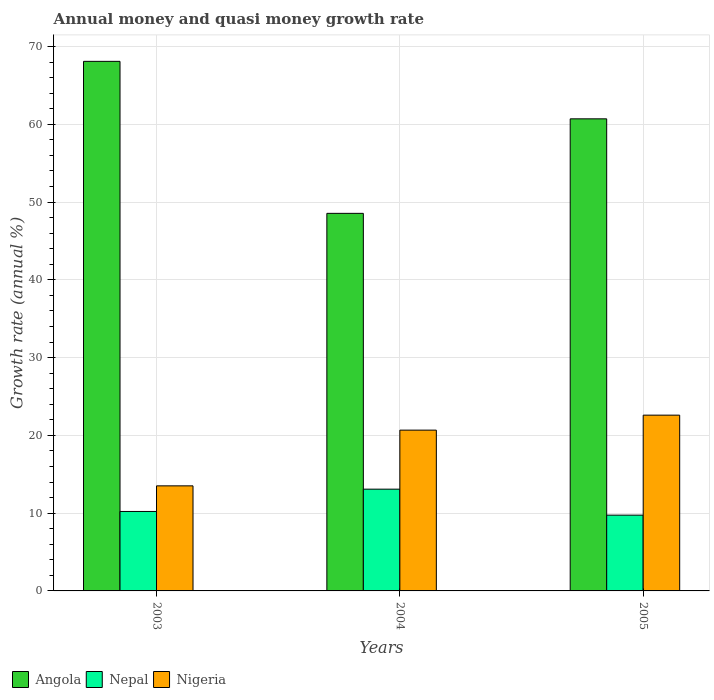How many groups of bars are there?
Give a very brief answer. 3. Are the number of bars per tick equal to the number of legend labels?
Provide a succinct answer. Yes. How many bars are there on the 1st tick from the left?
Provide a succinct answer. 3. How many bars are there on the 3rd tick from the right?
Provide a succinct answer. 3. What is the growth rate in Nepal in 2005?
Your response must be concise. 9.74. Across all years, what is the maximum growth rate in Nepal?
Offer a very short reply. 13.09. Across all years, what is the minimum growth rate in Nepal?
Give a very brief answer. 9.74. In which year was the growth rate in Nigeria maximum?
Your answer should be compact. 2005. In which year was the growth rate in Angola minimum?
Your response must be concise. 2004. What is the total growth rate in Nigeria in the graph?
Give a very brief answer. 56.79. What is the difference between the growth rate in Angola in 2003 and that in 2005?
Your answer should be compact. 7.39. What is the difference between the growth rate in Nigeria in 2005 and the growth rate in Nepal in 2004?
Give a very brief answer. 9.52. What is the average growth rate in Angola per year?
Keep it short and to the point. 59.12. In the year 2004, what is the difference between the growth rate in Nigeria and growth rate in Nepal?
Give a very brief answer. 7.59. In how many years, is the growth rate in Nepal greater than 40 %?
Ensure brevity in your answer.  0. What is the ratio of the growth rate in Nigeria in 2004 to that in 2005?
Your response must be concise. 0.91. Is the growth rate in Angola in 2003 less than that in 2004?
Ensure brevity in your answer.  No. Is the difference between the growth rate in Nigeria in 2003 and 2005 greater than the difference between the growth rate in Nepal in 2003 and 2005?
Your response must be concise. No. What is the difference between the highest and the second highest growth rate in Angola?
Keep it short and to the point. 7.39. What is the difference between the highest and the lowest growth rate in Nepal?
Keep it short and to the point. 3.34. What does the 1st bar from the left in 2004 represents?
Your answer should be compact. Angola. What does the 1st bar from the right in 2003 represents?
Ensure brevity in your answer.  Nigeria. Is it the case that in every year, the sum of the growth rate in Angola and growth rate in Nigeria is greater than the growth rate in Nepal?
Ensure brevity in your answer.  Yes. Are all the bars in the graph horizontal?
Keep it short and to the point. No. Does the graph contain grids?
Give a very brief answer. Yes. Where does the legend appear in the graph?
Your answer should be very brief. Bottom left. How many legend labels are there?
Your answer should be compact. 3. How are the legend labels stacked?
Make the answer very short. Horizontal. What is the title of the graph?
Your answer should be compact. Annual money and quasi money growth rate. Does "Ethiopia" appear as one of the legend labels in the graph?
Provide a short and direct response. No. What is the label or title of the Y-axis?
Offer a very short reply. Growth rate (annual %). What is the Growth rate (annual %) in Angola in 2003?
Offer a very short reply. 68.1. What is the Growth rate (annual %) of Nepal in 2003?
Provide a succinct answer. 10.22. What is the Growth rate (annual %) in Nigeria in 2003?
Offer a very short reply. 13.51. What is the Growth rate (annual %) of Angola in 2004?
Make the answer very short. 48.55. What is the Growth rate (annual %) of Nepal in 2004?
Give a very brief answer. 13.09. What is the Growth rate (annual %) in Nigeria in 2004?
Make the answer very short. 20.68. What is the Growth rate (annual %) of Angola in 2005?
Make the answer very short. 60.71. What is the Growth rate (annual %) in Nepal in 2005?
Ensure brevity in your answer.  9.74. What is the Growth rate (annual %) of Nigeria in 2005?
Provide a succinct answer. 22.6. Across all years, what is the maximum Growth rate (annual %) in Angola?
Your answer should be very brief. 68.1. Across all years, what is the maximum Growth rate (annual %) of Nepal?
Provide a succinct answer. 13.09. Across all years, what is the maximum Growth rate (annual %) in Nigeria?
Ensure brevity in your answer.  22.6. Across all years, what is the minimum Growth rate (annual %) in Angola?
Your answer should be very brief. 48.55. Across all years, what is the minimum Growth rate (annual %) of Nepal?
Give a very brief answer. 9.74. Across all years, what is the minimum Growth rate (annual %) in Nigeria?
Offer a terse response. 13.51. What is the total Growth rate (annual %) of Angola in the graph?
Give a very brief answer. 177.36. What is the total Growth rate (annual %) of Nepal in the graph?
Keep it short and to the point. 33.05. What is the total Growth rate (annual %) in Nigeria in the graph?
Ensure brevity in your answer.  56.79. What is the difference between the Growth rate (annual %) in Angola in 2003 and that in 2004?
Ensure brevity in your answer.  19.55. What is the difference between the Growth rate (annual %) in Nepal in 2003 and that in 2004?
Give a very brief answer. -2.87. What is the difference between the Growth rate (annual %) in Nigeria in 2003 and that in 2004?
Provide a succinct answer. -7.17. What is the difference between the Growth rate (annual %) in Angola in 2003 and that in 2005?
Give a very brief answer. 7.39. What is the difference between the Growth rate (annual %) in Nepal in 2003 and that in 2005?
Your answer should be very brief. 0.47. What is the difference between the Growth rate (annual %) of Nigeria in 2003 and that in 2005?
Make the answer very short. -9.09. What is the difference between the Growth rate (annual %) of Angola in 2004 and that in 2005?
Offer a very short reply. -12.15. What is the difference between the Growth rate (annual %) of Nepal in 2004 and that in 2005?
Give a very brief answer. 3.34. What is the difference between the Growth rate (annual %) in Nigeria in 2004 and that in 2005?
Make the answer very short. -1.93. What is the difference between the Growth rate (annual %) of Angola in 2003 and the Growth rate (annual %) of Nepal in 2004?
Provide a short and direct response. 55.01. What is the difference between the Growth rate (annual %) in Angola in 2003 and the Growth rate (annual %) in Nigeria in 2004?
Your response must be concise. 47.42. What is the difference between the Growth rate (annual %) of Nepal in 2003 and the Growth rate (annual %) of Nigeria in 2004?
Your response must be concise. -10.46. What is the difference between the Growth rate (annual %) of Angola in 2003 and the Growth rate (annual %) of Nepal in 2005?
Provide a short and direct response. 58.35. What is the difference between the Growth rate (annual %) in Angola in 2003 and the Growth rate (annual %) in Nigeria in 2005?
Your response must be concise. 45.49. What is the difference between the Growth rate (annual %) of Nepal in 2003 and the Growth rate (annual %) of Nigeria in 2005?
Keep it short and to the point. -12.39. What is the difference between the Growth rate (annual %) in Angola in 2004 and the Growth rate (annual %) in Nepal in 2005?
Ensure brevity in your answer.  38.81. What is the difference between the Growth rate (annual %) of Angola in 2004 and the Growth rate (annual %) of Nigeria in 2005?
Provide a short and direct response. 25.95. What is the difference between the Growth rate (annual %) in Nepal in 2004 and the Growth rate (annual %) in Nigeria in 2005?
Offer a terse response. -9.52. What is the average Growth rate (annual %) of Angola per year?
Provide a short and direct response. 59.12. What is the average Growth rate (annual %) of Nepal per year?
Offer a very short reply. 11.02. What is the average Growth rate (annual %) in Nigeria per year?
Ensure brevity in your answer.  18.93. In the year 2003, what is the difference between the Growth rate (annual %) of Angola and Growth rate (annual %) of Nepal?
Your answer should be compact. 57.88. In the year 2003, what is the difference between the Growth rate (annual %) of Angola and Growth rate (annual %) of Nigeria?
Keep it short and to the point. 54.59. In the year 2003, what is the difference between the Growth rate (annual %) in Nepal and Growth rate (annual %) in Nigeria?
Your response must be concise. -3.29. In the year 2004, what is the difference between the Growth rate (annual %) in Angola and Growth rate (annual %) in Nepal?
Your response must be concise. 35.47. In the year 2004, what is the difference between the Growth rate (annual %) of Angola and Growth rate (annual %) of Nigeria?
Offer a terse response. 27.87. In the year 2004, what is the difference between the Growth rate (annual %) of Nepal and Growth rate (annual %) of Nigeria?
Offer a terse response. -7.59. In the year 2005, what is the difference between the Growth rate (annual %) in Angola and Growth rate (annual %) in Nepal?
Offer a terse response. 50.96. In the year 2005, what is the difference between the Growth rate (annual %) of Angola and Growth rate (annual %) of Nigeria?
Your answer should be compact. 38.1. In the year 2005, what is the difference between the Growth rate (annual %) of Nepal and Growth rate (annual %) of Nigeria?
Offer a terse response. -12.86. What is the ratio of the Growth rate (annual %) of Angola in 2003 to that in 2004?
Keep it short and to the point. 1.4. What is the ratio of the Growth rate (annual %) of Nepal in 2003 to that in 2004?
Your answer should be compact. 0.78. What is the ratio of the Growth rate (annual %) in Nigeria in 2003 to that in 2004?
Give a very brief answer. 0.65. What is the ratio of the Growth rate (annual %) in Angola in 2003 to that in 2005?
Provide a short and direct response. 1.12. What is the ratio of the Growth rate (annual %) in Nepal in 2003 to that in 2005?
Provide a succinct answer. 1.05. What is the ratio of the Growth rate (annual %) of Nigeria in 2003 to that in 2005?
Make the answer very short. 0.6. What is the ratio of the Growth rate (annual %) in Angola in 2004 to that in 2005?
Offer a terse response. 0.8. What is the ratio of the Growth rate (annual %) in Nepal in 2004 to that in 2005?
Provide a succinct answer. 1.34. What is the ratio of the Growth rate (annual %) of Nigeria in 2004 to that in 2005?
Offer a very short reply. 0.91. What is the difference between the highest and the second highest Growth rate (annual %) in Angola?
Provide a succinct answer. 7.39. What is the difference between the highest and the second highest Growth rate (annual %) of Nepal?
Offer a terse response. 2.87. What is the difference between the highest and the second highest Growth rate (annual %) in Nigeria?
Offer a terse response. 1.93. What is the difference between the highest and the lowest Growth rate (annual %) in Angola?
Keep it short and to the point. 19.55. What is the difference between the highest and the lowest Growth rate (annual %) of Nepal?
Offer a terse response. 3.34. What is the difference between the highest and the lowest Growth rate (annual %) of Nigeria?
Offer a very short reply. 9.09. 